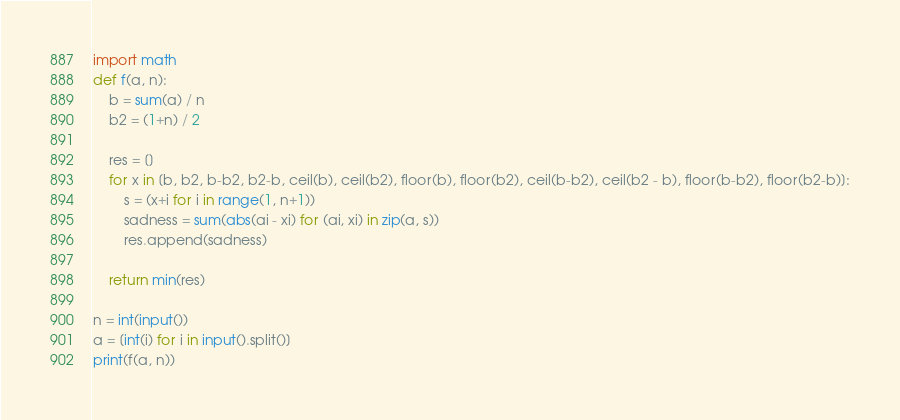<code> <loc_0><loc_0><loc_500><loc_500><_Python_>import math
def f(a, n):
    b = sum(a) / n
    b2 = (1+n) / 2 
    
    res = []
    for x in [b, b2, b-b2, b2-b, ceil(b), ceil(b2), floor(b), floor(b2), ceil(b-b2), ceil(b2 - b), floor(b-b2), floor(b2-b)]:
        s = (x+i for i in range(1, n+1))
        sadness = sum(abs(ai - xi) for (ai, xi) in zip(a, s))
        res.append(sadness)
        
    return min(res)
    
n = int(input())
a = [int(i) for i in input().split()]
print(f(a, n))
</code> 